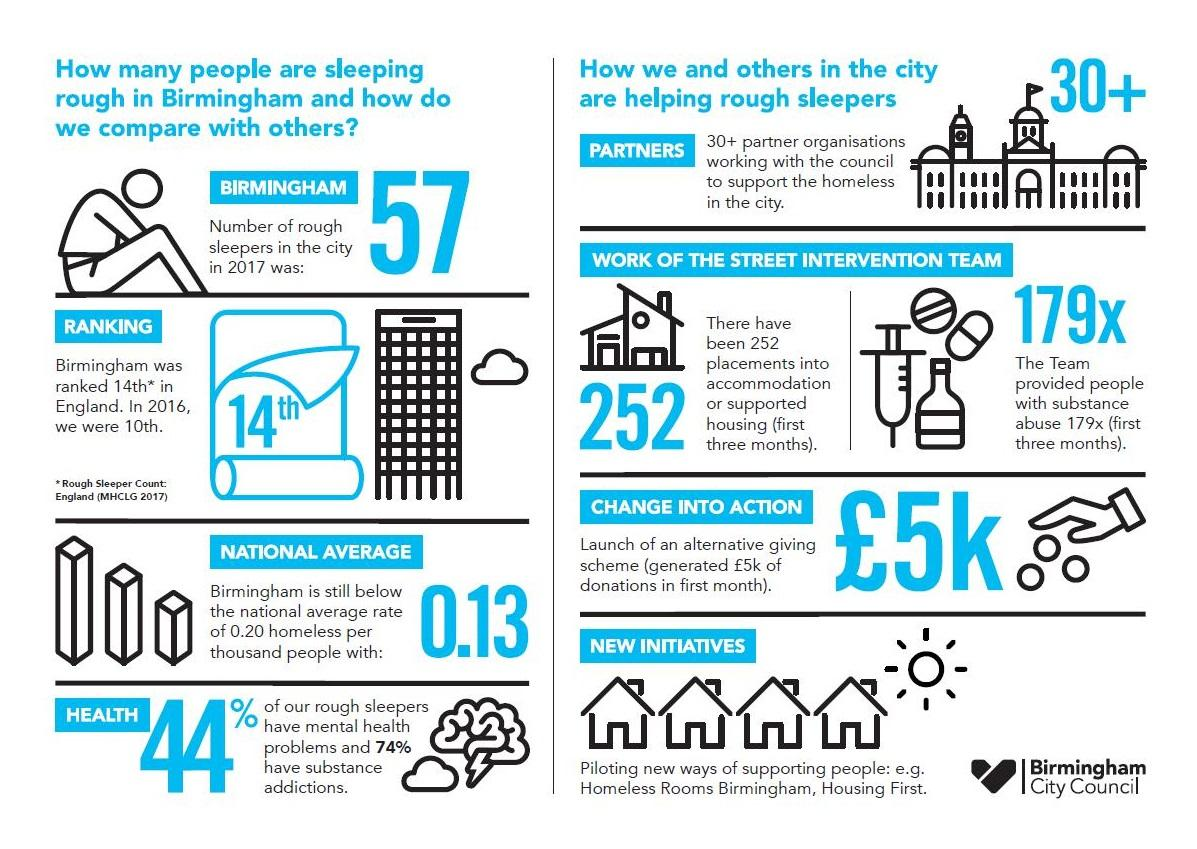Outline some significant characteristics in this image. In 2017, a survey conducted in Birmingham city found that only 56% of rough sleepers did not have mental health problems. According to a report from 2017, a significant majority of rough sleepers in Birmingham, 74%, had substance addictions. The average rate of homeless people in Birmingham city in 2017 was 0.13%. In 2016, Birmingham ranked 10th in terms of rough sleeper count. 